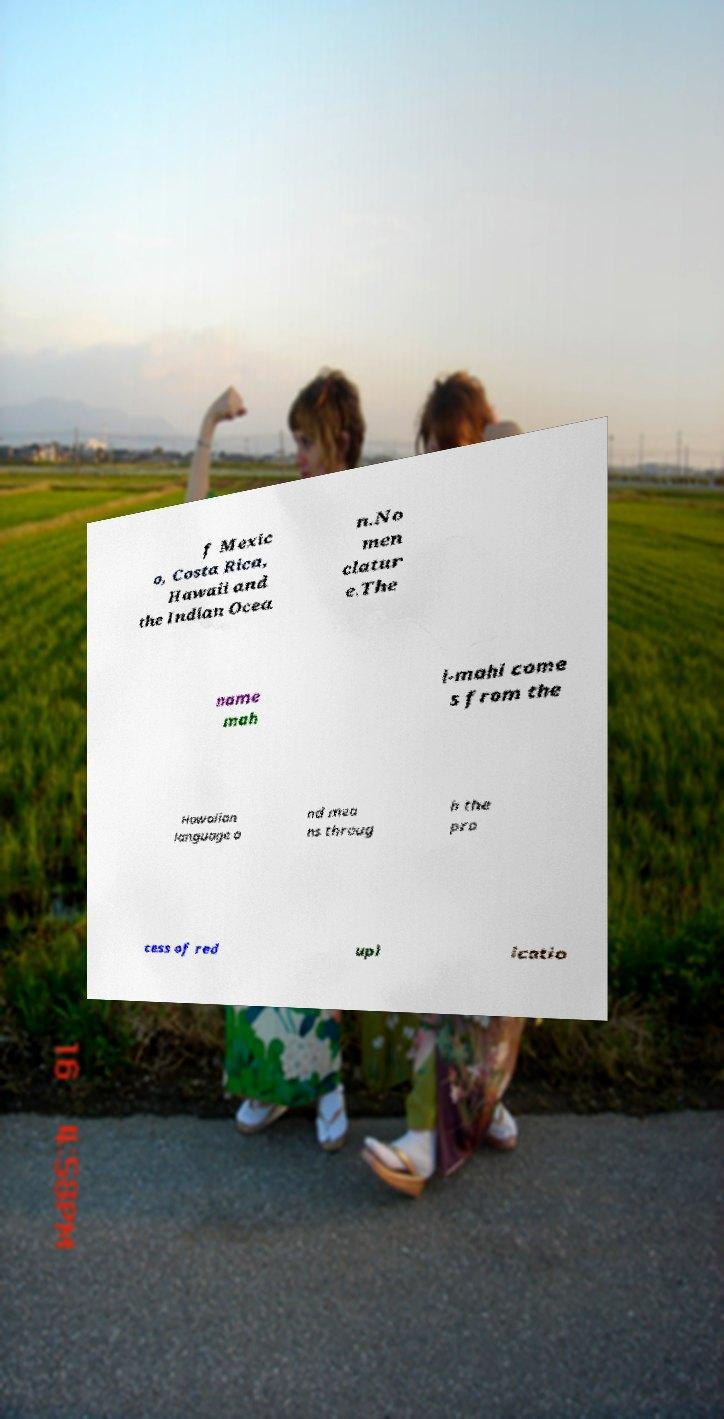Please identify and transcribe the text found in this image. f Mexic o, Costa Rica, Hawaii and the Indian Ocea n.No men clatur e.The name mah i-mahi come s from the Hawaiian language a nd mea ns throug h the pro cess of red upl icatio 